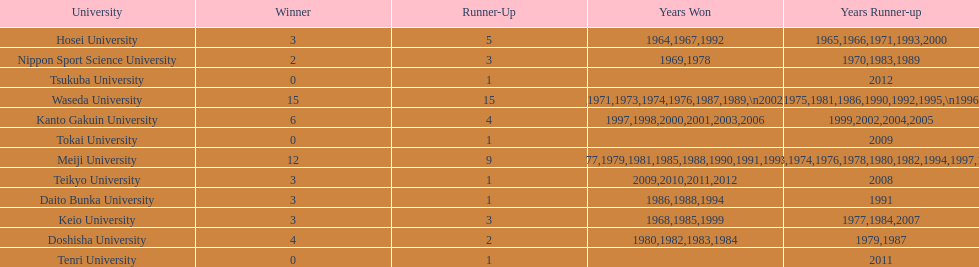Which universities had a number of wins higher than 12? Waseda University. 